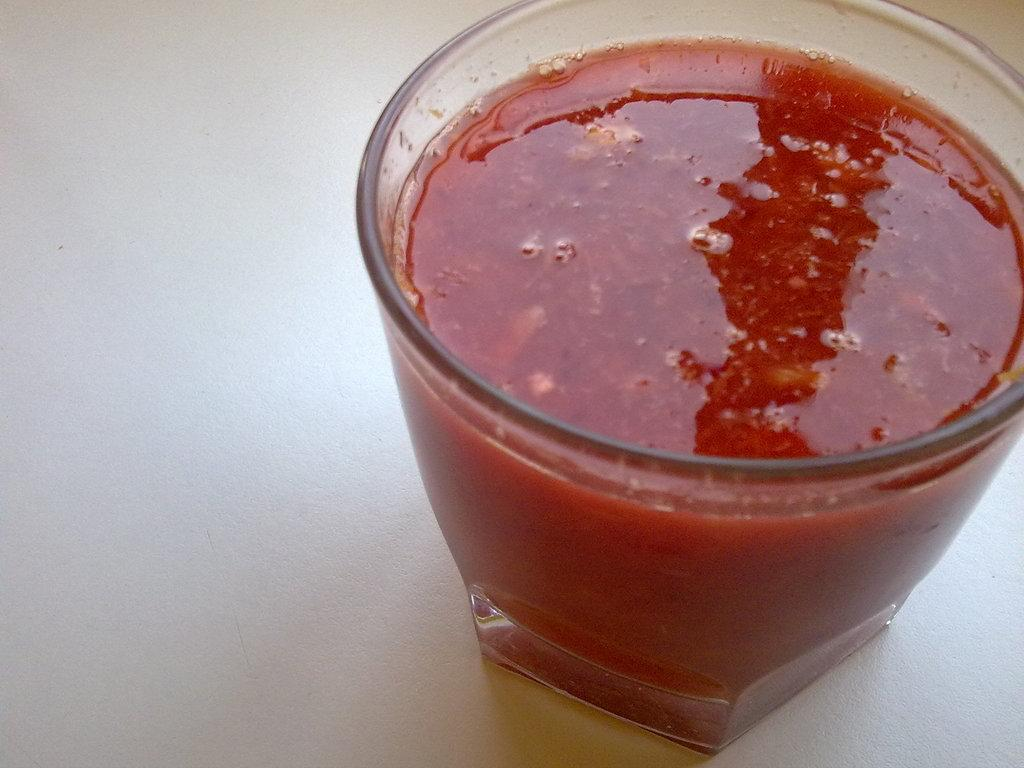What is present in the image that can hold a liquid or substance? There is a glass in the image. What can be seen inside the glass? The glass contains a red-colored substance or object. Can you see the glass crying in the image? No, the glass is not depicted as crying in the image. 